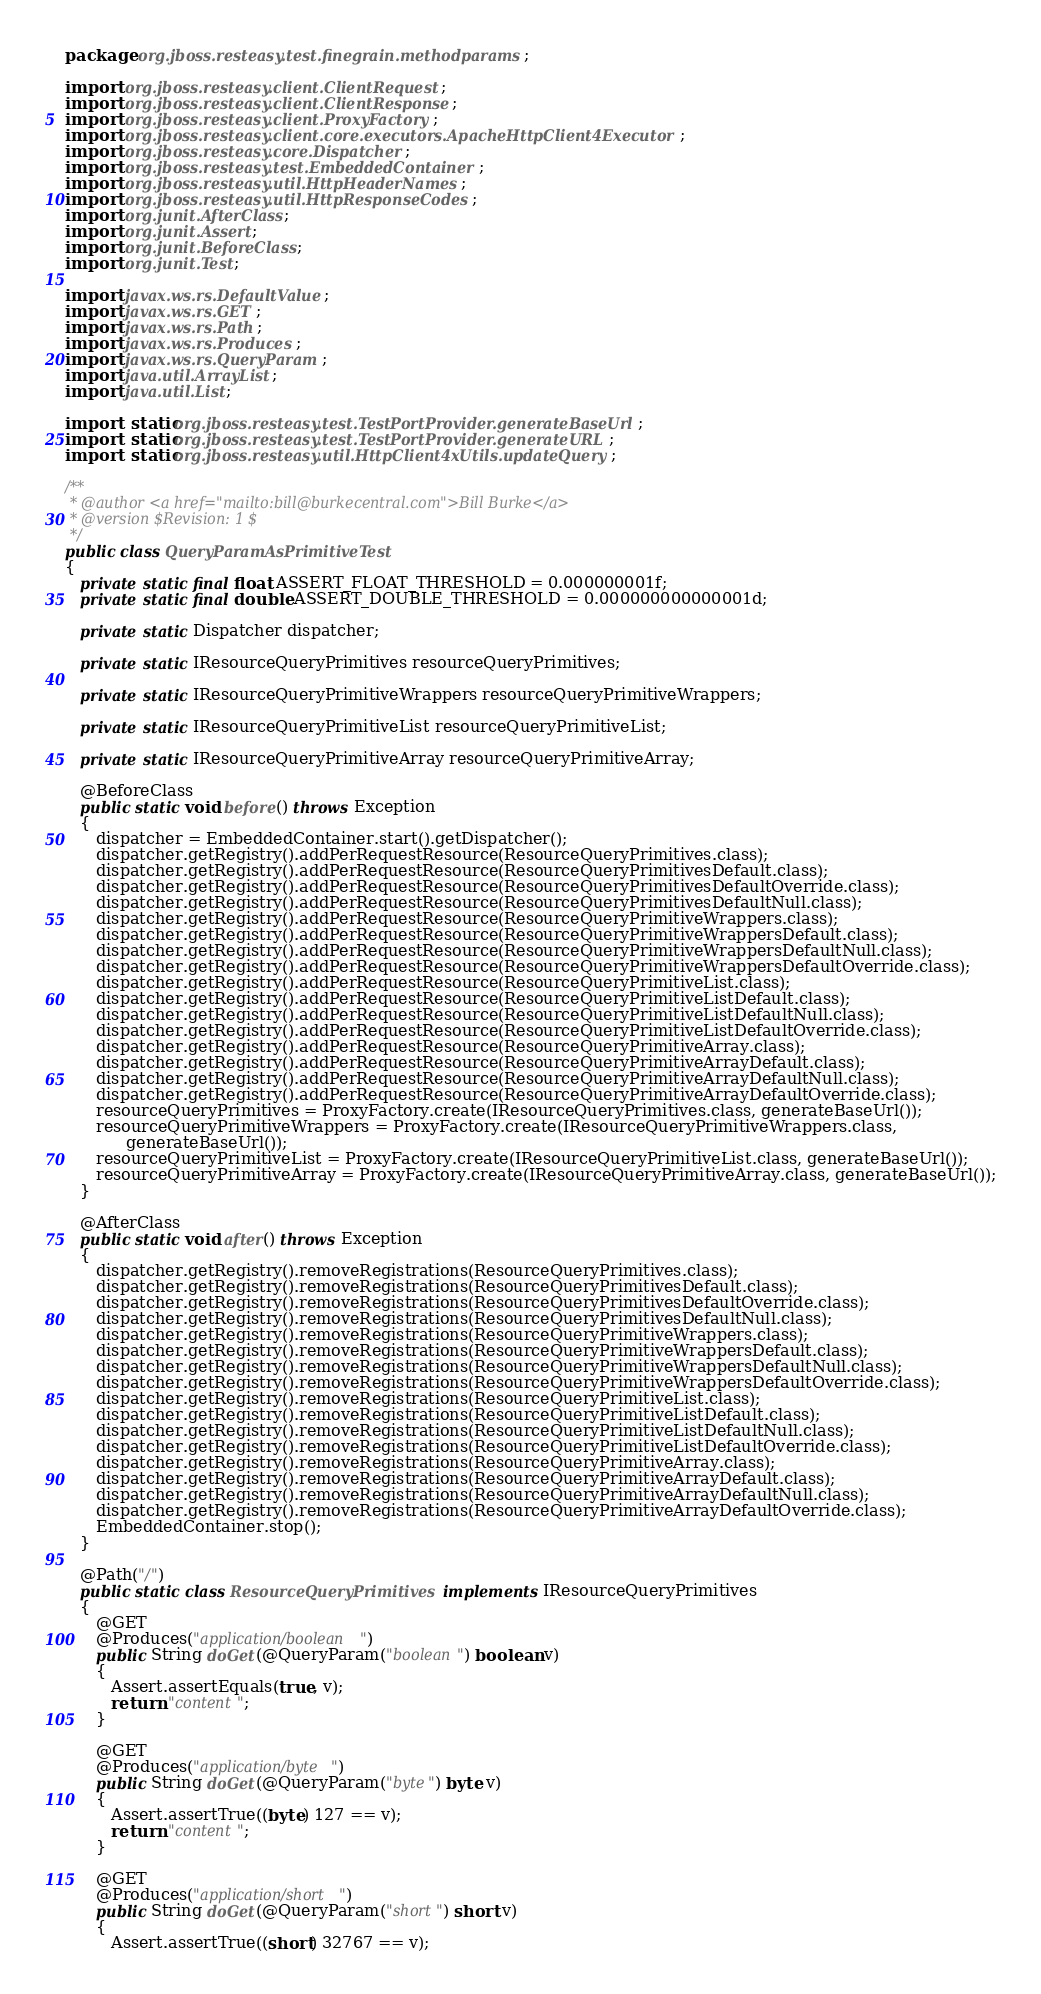<code> <loc_0><loc_0><loc_500><loc_500><_Java_>package org.jboss.resteasy.test.finegrain.methodparams;

import org.jboss.resteasy.client.ClientRequest;
import org.jboss.resteasy.client.ClientResponse;
import org.jboss.resteasy.client.ProxyFactory;
import org.jboss.resteasy.client.core.executors.ApacheHttpClient4Executor;
import org.jboss.resteasy.core.Dispatcher;
import org.jboss.resteasy.test.EmbeddedContainer;
import org.jboss.resteasy.util.HttpHeaderNames;
import org.jboss.resteasy.util.HttpResponseCodes;
import org.junit.AfterClass;
import org.junit.Assert;
import org.junit.BeforeClass;
import org.junit.Test;

import javax.ws.rs.DefaultValue;
import javax.ws.rs.GET;
import javax.ws.rs.Path;
import javax.ws.rs.Produces;
import javax.ws.rs.QueryParam;
import java.util.ArrayList;
import java.util.List;

import static org.jboss.resteasy.test.TestPortProvider.generateBaseUrl;
import static org.jboss.resteasy.test.TestPortProvider.generateURL;
import static org.jboss.resteasy.util.HttpClient4xUtils.updateQuery;

/**
 * @author <a href="mailto:bill@burkecentral.com">Bill Burke</a>
 * @version $Revision: 1 $
 */
public class QueryParamAsPrimitiveTest
{
   private static final float ASSERT_FLOAT_THRESHOLD = 0.000000001f;
   private static final double ASSERT_DOUBLE_THRESHOLD = 0.000000000000001d;

   private static Dispatcher dispatcher;

   private static IResourceQueryPrimitives resourceQueryPrimitives;

   private static IResourceQueryPrimitiveWrappers resourceQueryPrimitiveWrappers;

   private static IResourceQueryPrimitiveList resourceQueryPrimitiveList;

   private static IResourceQueryPrimitiveArray resourceQueryPrimitiveArray;

   @BeforeClass
   public static void before() throws Exception
   {
      dispatcher = EmbeddedContainer.start().getDispatcher();
      dispatcher.getRegistry().addPerRequestResource(ResourceQueryPrimitives.class);
      dispatcher.getRegistry().addPerRequestResource(ResourceQueryPrimitivesDefault.class);
      dispatcher.getRegistry().addPerRequestResource(ResourceQueryPrimitivesDefaultOverride.class);
      dispatcher.getRegistry().addPerRequestResource(ResourceQueryPrimitivesDefaultNull.class);
      dispatcher.getRegistry().addPerRequestResource(ResourceQueryPrimitiveWrappers.class);
      dispatcher.getRegistry().addPerRequestResource(ResourceQueryPrimitiveWrappersDefault.class);
      dispatcher.getRegistry().addPerRequestResource(ResourceQueryPrimitiveWrappersDefaultNull.class);
      dispatcher.getRegistry().addPerRequestResource(ResourceQueryPrimitiveWrappersDefaultOverride.class);
      dispatcher.getRegistry().addPerRequestResource(ResourceQueryPrimitiveList.class);
      dispatcher.getRegistry().addPerRequestResource(ResourceQueryPrimitiveListDefault.class);
      dispatcher.getRegistry().addPerRequestResource(ResourceQueryPrimitiveListDefaultNull.class);
      dispatcher.getRegistry().addPerRequestResource(ResourceQueryPrimitiveListDefaultOverride.class);
      dispatcher.getRegistry().addPerRequestResource(ResourceQueryPrimitiveArray.class);
      dispatcher.getRegistry().addPerRequestResource(ResourceQueryPrimitiveArrayDefault.class);
      dispatcher.getRegistry().addPerRequestResource(ResourceQueryPrimitiveArrayDefaultNull.class);
      dispatcher.getRegistry().addPerRequestResource(ResourceQueryPrimitiveArrayDefaultOverride.class);
      resourceQueryPrimitives = ProxyFactory.create(IResourceQueryPrimitives.class, generateBaseUrl());
      resourceQueryPrimitiveWrappers = ProxyFactory.create(IResourceQueryPrimitiveWrappers.class,
            generateBaseUrl());
      resourceQueryPrimitiveList = ProxyFactory.create(IResourceQueryPrimitiveList.class, generateBaseUrl());
      resourceQueryPrimitiveArray = ProxyFactory.create(IResourceQueryPrimitiveArray.class, generateBaseUrl());
   }

   @AfterClass
   public static void after() throws Exception
   {
      dispatcher.getRegistry().removeRegistrations(ResourceQueryPrimitives.class);
      dispatcher.getRegistry().removeRegistrations(ResourceQueryPrimitivesDefault.class);
      dispatcher.getRegistry().removeRegistrations(ResourceQueryPrimitivesDefaultOverride.class);
      dispatcher.getRegistry().removeRegistrations(ResourceQueryPrimitivesDefaultNull.class);
      dispatcher.getRegistry().removeRegistrations(ResourceQueryPrimitiveWrappers.class);
      dispatcher.getRegistry().removeRegistrations(ResourceQueryPrimitiveWrappersDefault.class);
      dispatcher.getRegistry().removeRegistrations(ResourceQueryPrimitiveWrappersDefaultNull.class);
      dispatcher.getRegistry().removeRegistrations(ResourceQueryPrimitiveWrappersDefaultOverride.class);
      dispatcher.getRegistry().removeRegistrations(ResourceQueryPrimitiveList.class);
      dispatcher.getRegistry().removeRegistrations(ResourceQueryPrimitiveListDefault.class);
      dispatcher.getRegistry().removeRegistrations(ResourceQueryPrimitiveListDefaultNull.class);
      dispatcher.getRegistry().removeRegistrations(ResourceQueryPrimitiveListDefaultOverride.class);
      dispatcher.getRegistry().removeRegistrations(ResourceQueryPrimitiveArray.class);
      dispatcher.getRegistry().removeRegistrations(ResourceQueryPrimitiveArrayDefault.class);
      dispatcher.getRegistry().removeRegistrations(ResourceQueryPrimitiveArrayDefaultNull.class);
      dispatcher.getRegistry().removeRegistrations(ResourceQueryPrimitiveArrayDefaultOverride.class);
      EmbeddedContainer.stop();
   }

   @Path("/")
   public static class ResourceQueryPrimitives implements IResourceQueryPrimitives
   {
      @GET
      @Produces("application/boolean")
      public String doGet(@QueryParam("boolean") boolean v)
      {
         Assert.assertEquals(true, v);
         return "content";
      }

      @GET
      @Produces("application/byte")
      public String doGet(@QueryParam("byte") byte v)
      {
         Assert.assertTrue((byte) 127 == v);
         return "content";
      }

      @GET
      @Produces("application/short")
      public String doGet(@QueryParam("short") short v)
      {
         Assert.assertTrue((short) 32767 == v);</code> 